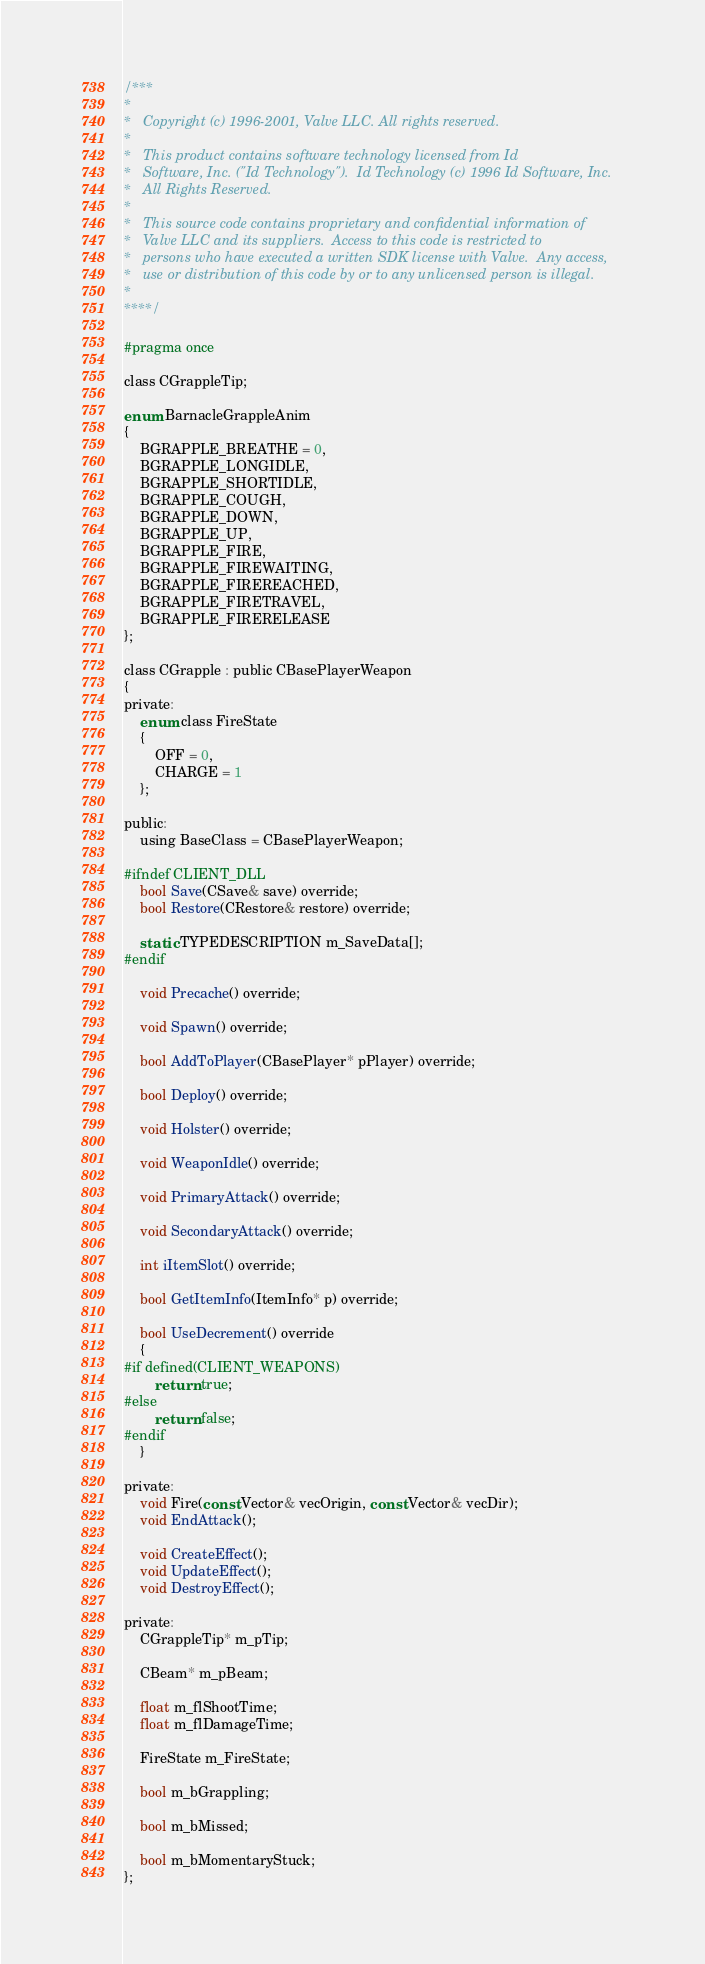<code> <loc_0><loc_0><loc_500><loc_500><_C_>/***
*
*	Copyright (c) 1996-2001, Valve LLC. All rights reserved.
*
*	This product contains software technology licensed from Id
*	Software, Inc. ("Id Technology").  Id Technology (c) 1996 Id Software, Inc.
*	All Rights Reserved.
*
*   This source code contains proprietary and confidential information of
*   Valve LLC and its suppliers.  Access to this code is restricted to
*   persons who have executed a written SDK license with Valve.  Any access,
*   use or distribution of this code by or to any unlicensed person is illegal.
*
****/

#pragma once

class CGrappleTip;

enum BarnacleGrappleAnim
{
	BGRAPPLE_BREATHE = 0,
	BGRAPPLE_LONGIDLE,
	BGRAPPLE_SHORTIDLE,
	BGRAPPLE_COUGH,
	BGRAPPLE_DOWN,
	BGRAPPLE_UP,
	BGRAPPLE_FIRE,
	BGRAPPLE_FIREWAITING,
	BGRAPPLE_FIREREACHED,
	BGRAPPLE_FIRETRAVEL,
	BGRAPPLE_FIRERELEASE
};

class CGrapple : public CBasePlayerWeapon
{
private:
	enum class FireState
	{
		OFF = 0,
		CHARGE = 1
	};

public:
	using BaseClass = CBasePlayerWeapon;

#ifndef CLIENT_DLL
	bool Save(CSave& save) override;
	bool Restore(CRestore& restore) override;

	static TYPEDESCRIPTION m_SaveData[];
#endif

	void Precache() override;

	void Spawn() override;

	bool AddToPlayer(CBasePlayer* pPlayer) override;

	bool Deploy() override;

	void Holster() override;

	void WeaponIdle() override;

	void PrimaryAttack() override;

	void SecondaryAttack() override;

	int iItemSlot() override;

	bool GetItemInfo(ItemInfo* p) override;

	bool UseDecrement() override
	{
#if defined(CLIENT_WEAPONS)
		return true;
#else
		return false;
#endif
	}

private:
	void Fire(const Vector& vecOrigin, const Vector& vecDir);
	void EndAttack();

	void CreateEffect();
	void UpdateEffect();
	void DestroyEffect();

private:
	CGrappleTip* m_pTip;

	CBeam* m_pBeam;

	float m_flShootTime;
	float m_flDamageTime;

	FireState m_FireState;

	bool m_bGrappling;

	bool m_bMissed;

	bool m_bMomentaryStuck;
};
</code> 